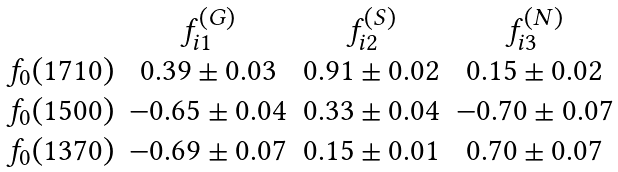Convert formula to latex. <formula><loc_0><loc_0><loc_500><loc_500>\begin{array} { c c c c } & f _ { i 1 } ^ { ( G ) } & f _ { i 2 } ^ { ( S ) } & f _ { i 3 } ^ { ( N ) } \\ f _ { 0 } ( 1 7 1 0 ) & 0 . 3 9 \pm 0 . 0 3 & 0 . 9 1 \pm 0 . 0 2 & 0 . 1 5 \pm 0 . 0 2 \\ f _ { 0 } ( 1 5 0 0 ) & - 0 . 6 5 \pm 0 . 0 4 & 0 . 3 3 \pm 0 . 0 4 & - 0 . 7 0 \pm 0 . 0 7 \\ f _ { 0 } ( 1 3 7 0 ) & - 0 . 6 9 \pm 0 . 0 7 & 0 . 1 5 \pm 0 . 0 1 & 0 . 7 0 \pm 0 . 0 7 \\ \end{array}</formula> 